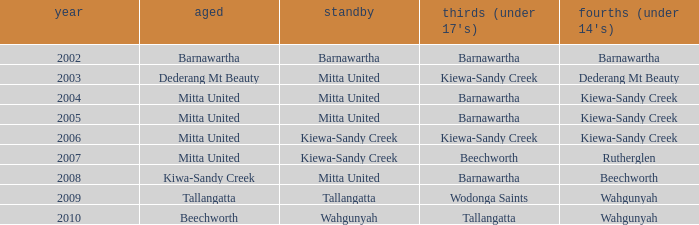Which seniors have a year before 2007, Fourths (Under 14's) of kiewa-sandy creek, and a Reserve of mitta united? Mitta United, Mitta United. 